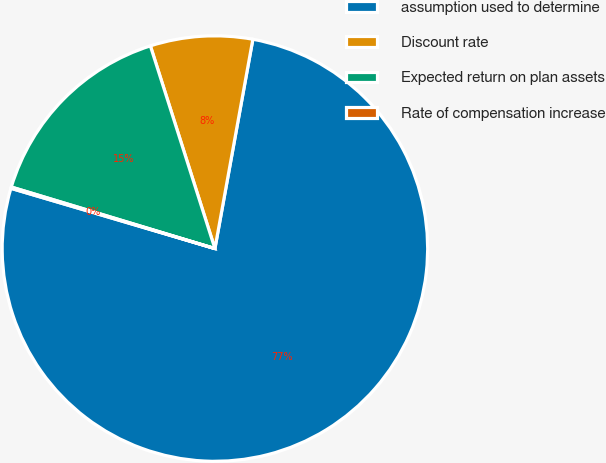<chart> <loc_0><loc_0><loc_500><loc_500><pie_chart><fcel>assumption used to determine<fcel>Discount rate<fcel>Expected return on plan assets<fcel>Rate of compensation increase<nl><fcel>76.71%<fcel>7.76%<fcel>15.42%<fcel>0.1%<nl></chart> 